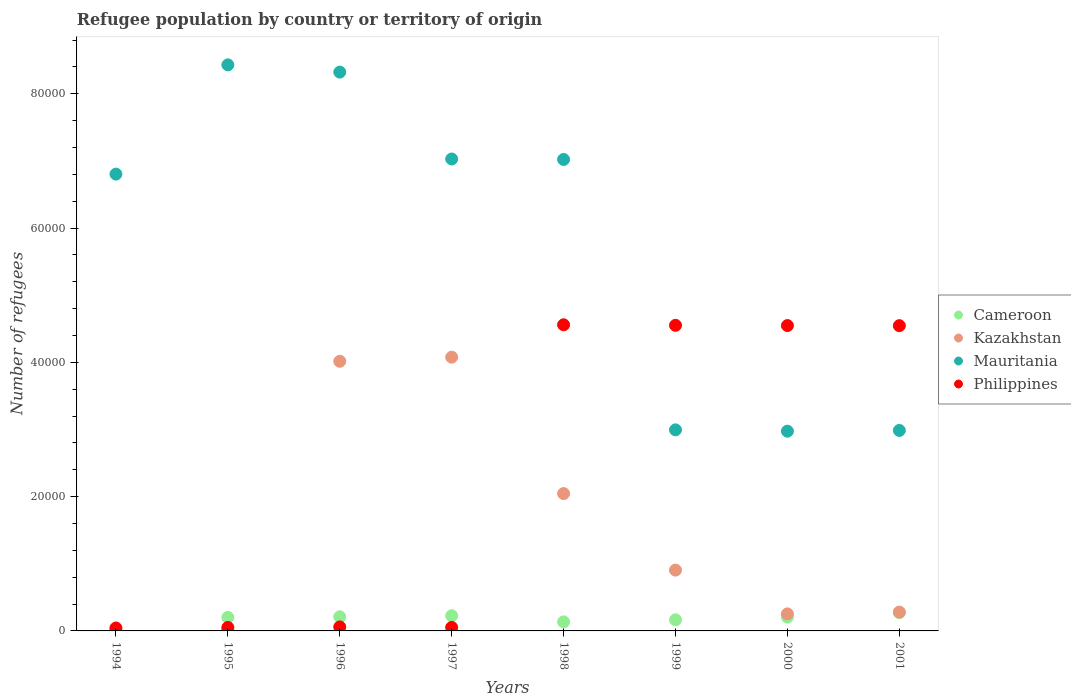How many different coloured dotlines are there?
Offer a terse response. 4. What is the number of refugees in Mauritania in 1994?
Provide a short and direct response. 6.80e+04. Across all years, what is the maximum number of refugees in Philippines?
Your answer should be compact. 4.56e+04. Across all years, what is the minimum number of refugees in Cameroon?
Provide a short and direct response. 238. In which year was the number of refugees in Mauritania maximum?
Your response must be concise. 1995. In which year was the number of refugees in Mauritania minimum?
Keep it short and to the point. 2000. What is the total number of refugees in Mauritania in the graph?
Your answer should be compact. 4.66e+05. What is the difference between the number of refugees in Mauritania in 1994 and that in 2000?
Your answer should be very brief. 3.83e+04. What is the difference between the number of refugees in Cameroon in 1998 and the number of refugees in Kazakhstan in 2001?
Offer a terse response. -1455. What is the average number of refugees in Mauritania per year?
Your answer should be very brief. 5.82e+04. In the year 1997, what is the difference between the number of refugees in Mauritania and number of refugees in Philippines?
Offer a very short reply. 6.98e+04. In how many years, is the number of refugees in Philippines greater than 28000?
Offer a very short reply. 4. What is the ratio of the number of refugees in Cameroon in 2000 to that in 2001?
Your answer should be very brief. 0.76. Is the number of refugees in Philippines in 1995 less than that in 1998?
Offer a very short reply. Yes. What is the difference between the highest and the second highest number of refugees in Cameroon?
Your answer should be compact. 466. What is the difference between the highest and the lowest number of refugees in Kazakhstan?
Provide a succinct answer. 4.07e+04. Does the number of refugees in Cameroon monotonically increase over the years?
Ensure brevity in your answer.  No. Is the number of refugees in Mauritania strictly greater than the number of refugees in Cameroon over the years?
Make the answer very short. Yes. Is the number of refugees in Philippines strictly less than the number of refugees in Mauritania over the years?
Ensure brevity in your answer.  No. How many dotlines are there?
Keep it short and to the point. 4. How many years are there in the graph?
Keep it short and to the point. 8. Are the values on the major ticks of Y-axis written in scientific E-notation?
Provide a short and direct response. No. How many legend labels are there?
Keep it short and to the point. 4. What is the title of the graph?
Ensure brevity in your answer.  Refugee population by country or territory of origin. Does "Central African Republic" appear as one of the legend labels in the graph?
Offer a terse response. No. What is the label or title of the X-axis?
Provide a succinct answer. Years. What is the label or title of the Y-axis?
Offer a very short reply. Number of refugees. What is the Number of refugees in Cameroon in 1994?
Your answer should be very brief. 238. What is the Number of refugees in Kazakhstan in 1994?
Ensure brevity in your answer.  27. What is the Number of refugees in Mauritania in 1994?
Your response must be concise. 6.80e+04. What is the Number of refugees of Philippines in 1994?
Your answer should be very brief. 436. What is the Number of refugees of Cameroon in 1995?
Ensure brevity in your answer.  2017. What is the Number of refugees in Kazakhstan in 1995?
Provide a succinct answer. 139. What is the Number of refugees in Mauritania in 1995?
Ensure brevity in your answer.  8.43e+04. What is the Number of refugees of Philippines in 1995?
Give a very brief answer. 516. What is the Number of refugees of Cameroon in 1996?
Your answer should be very brief. 2109. What is the Number of refugees of Kazakhstan in 1996?
Make the answer very short. 4.02e+04. What is the Number of refugees of Mauritania in 1996?
Give a very brief answer. 8.32e+04. What is the Number of refugees in Philippines in 1996?
Your response must be concise. 598. What is the Number of refugees of Cameroon in 1997?
Your answer should be compact. 2258. What is the Number of refugees of Kazakhstan in 1997?
Ensure brevity in your answer.  4.08e+04. What is the Number of refugees of Mauritania in 1997?
Provide a succinct answer. 7.03e+04. What is the Number of refugees of Philippines in 1997?
Your answer should be very brief. 525. What is the Number of refugees of Cameroon in 1998?
Your answer should be compact. 1348. What is the Number of refugees of Kazakhstan in 1998?
Offer a very short reply. 2.05e+04. What is the Number of refugees of Mauritania in 1998?
Provide a short and direct response. 7.02e+04. What is the Number of refugees in Philippines in 1998?
Give a very brief answer. 4.56e+04. What is the Number of refugees of Cameroon in 1999?
Provide a short and direct response. 1654. What is the Number of refugees in Kazakhstan in 1999?
Your response must be concise. 9057. What is the Number of refugees of Mauritania in 1999?
Offer a very short reply. 2.99e+04. What is the Number of refugees in Philippines in 1999?
Your response must be concise. 4.55e+04. What is the Number of refugees of Cameroon in 2000?
Give a very brief answer. 2062. What is the Number of refugees in Kazakhstan in 2000?
Keep it short and to the point. 2537. What is the Number of refugees in Mauritania in 2000?
Your response must be concise. 2.98e+04. What is the Number of refugees of Philippines in 2000?
Offer a very short reply. 4.55e+04. What is the Number of refugees in Cameroon in 2001?
Ensure brevity in your answer.  2724. What is the Number of refugees of Kazakhstan in 2001?
Keep it short and to the point. 2803. What is the Number of refugees of Mauritania in 2001?
Offer a very short reply. 2.99e+04. What is the Number of refugees in Philippines in 2001?
Offer a very short reply. 4.55e+04. Across all years, what is the maximum Number of refugees in Cameroon?
Your answer should be very brief. 2724. Across all years, what is the maximum Number of refugees in Kazakhstan?
Make the answer very short. 4.08e+04. Across all years, what is the maximum Number of refugees of Mauritania?
Offer a terse response. 8.43e+04. Across all years, what is the maximum Number of refugees of Philippines?
Provide a short and direct response. 4.56e+04. Across all years, what is the minimum Number of refugees of Cameroon?
Your answer should be compact. 238. Across all years, what is the minimum Number of refugees in Kazakhstan?
Ensure brevity in your answer.  27. Across all years, what is the minimum Number of refugees in Mauritania?
Your response must be concise. 2.98e+04. Across all years, what is the minimum Number of refugees in Philippines?
Your answer should be very brief. 436. What is the total Number of refugees of Cameroon in the graph?
Offer a terse response. 1.44e+04. What is the total Number of refugees in Kazakhstan in the graph?
Ensure brevity in your answer.  1.16e+05. What is the total Number of refugees in Mauritania in the graph?
Your answer should be compact. 4.66e+05. What is the total Number of refugees in Philippines in the graph?
Provide a short and direct response. 1.84e+05. What is the difference between the Number of refugees of Cameroon in 1994 and that in 1995?
Ensure brevity in your answer.  -1779. What is the difference between the Number of refugees in Kazakhstan in 1994 and that in 1995?
Your answer should be very brief. -112. What is the difference between the Number of refugees of Mauritania in 1994 and that in 1995?
Make the answer very short. -1.63e+04. What is the difference between the Number of refugees in Philippines in 1994 and that in 1995?
Provide a short and direct response. -80. What is the difference between the Number of refugees in Cameroon in 1994 and that in 1996?
Give a very brief answer. -1871. What is the difference between the Number of refugees in Kazakhstan in 1994 and that in 1996?
Provide a succinct answer. -4.01e+04. What is the difference between the Number of refugees in Mauritania in 1994 and that in 1996?
Provide a short and direct response. -1.52e+04. What is the difference between the Number of refugees of Philippines in 1994 and that in 1996?
Provide a short and direct response. -162. What is the difference between the Number of refugees in Cameroon in 1994 and that in 1997?
Your response must be concise. -2020. What is the difference between the Number of refugees in Kazakhstan in 1994 and that in 1997?
Your answer should be compact. -4.07e+04. What is the difference between the Number of refugees in Mauritania in 1994 and that in 1997?
Make the answer very short. -2251. What is the difference between the Number of refugees in Philippines in 1994 and that in 1997?
Make the answer very short. -89. What is the difference between the Number of refugees of Cameroon in 1994 and that in 1998?
Your answer should be compact. -1110. What is the difference between the Number of refugees in Kazakhstan in 1994 and that in 1998?
Make the answer very short. -2.04e+04. What is the difference between the Number of refugees of Mauritania in 1994 and that in 1998?
Your answer should be very brief. -2181. What is the difference between the Number of refugees of Philippines in 1994 and that in 1998?
Give a very brief answer. -4.52e+04. What is the difference between the Number of refugees in Cameroon in 1994 and that in 1999?
Offer a very short reply. -1416. What is the difference between the Number of refugees in Kazakhstan in 1994 and that in 1999?
Offer a terse response. -9030. What is the difference between the Number of refugees of Mauritania in 1994 and that in 1999?
Your response must be concise. 3.81e+04. What is the difference between the Number of refugees in Philippines in 1994 and that in 1999?
Offer a very short reply. -4.51e+04. What is the difference between the Number of refugees of Cameroon in 1994 and that in 2000?
Offer a very short reply. -1824. What is the difference between the Number of refugees in Kazakhstan in 1994 and that in 2000?
Give a very brief answer. -2510. What is the difference between the Number of refugees of Mauritania in 1994 and that in 2000?
Your answer should be compact. 3.83e+04. What is the difference between the Number of refugees of Philippines in 1994 and that in 2000?
Offer a very short reply. -4.50e+04. What is the difference between the Number of refugees of Cameroon in 1994 and that in 2001?
Ensure brevity in your answer.  -2486. What is the difference between the Number of refugees of Kazakhstan in 1994 and that in 2001?
Offer a terse response. -2776. What is the difference between the Number of refugees of Mauritania in 1994 and that in 2001?
Provide a succinct answer. 3.82e+04. What is the difference between the Number of refugees in Philippines in 1994 and that in 2001?
Keep it short and to the point. -4.50e+04. What is the difference between the Number of refugees in Cameroon in 1995 and that in 1996?
Your response must be concise. -92. What is the difference between the Number of refugees in Kazakhstan in 1995 and that in 1996?
Provide a succinct answer. -4.00e+04. What is the difference between the Number of refugees of Mauritania in 1995 and that in 1996?
Offer a terse response. 1078. What is the difference between the Number of refugees in Philippines in 1995 and that in 1996?
Keep it short and to the point. -82. What is the difference between the Number of refugees in Cameroon in 1995 and that in 1997?
Your answer should be compact. -241. What is the difference between the Number of refugees of Kazakhstan in 1995 and that in 1997?
Your answer should be very brief. -4.06e+04. What is the difference between the Number of refugees of Mauritania in 1995 and that in 1997?
Your response must be concise. 1.40e+04. What is the difference between the Number of refugees of Philippines in 1995 and that in 1997?
Ensure brevity in your answer.  -9. What is the difference between the Number of refugees in Cameroon in 1995 and that in 1998?
Offer a very short reply. 669. What is the difference between the Number of refugees in Kazakhstan in 1995 and that in 1998?
Make the answer very short. -2.03e+04. What is the difference between the Number of refugees of Mauritania in 1995 and that in 1998?
Ensure brevity in your answer.  1.41e+04. What is the difference between the Number of refugees in Philippines in 1995 and that in 1998?
Offer a very short reply. -4.51e+04. What is the difference between the Number of refugees of Cameroon in 1995 and that in 1999?
Give a very brief answer. 363. What is the difference between the Number of refugees in Kazakhstan in 1995 and that in 1999?
Keep it short and to the point. -8918. What is the difference between the Number of refugees of Mauritania in 1995 and that in 1999?
Ensure brevity in your answer.  5.44e+04. What is the difference between the Number of refugees of Philippines in 1995 and that in 1999?
Your answer should be very brief. -4.50e+04. What is the difference between the Number of refugees of Cameroon in 1995 and that in 2000?
Your answer should be very brief. -45. What is the difference between the Number of refugees in Kazakhstan in 1995 and that in 2000?
Make the answer very short. -2398. What is the difference between the Number of refugees in Mauritania in 1995 and that in 2000?
Ensure brevity in your answer.  5.46e+04. What is the difference between the Number of refugees of Philippines in 1995 and that in 2000?
Your answer should be compact. -4.50e+04. What is the difference between the Number of refugees of Cameroon in 1995 and that in 2001?
Offer a very short reply. -707. What is the difference between the Number of refugees in Kazakhstan in 1995 and that in 2001?
Ensure brevity in your answer.  -2664. What is the difference between the Number of refugees in Mauritania in 1995 and that in 2001?
Your response must be concise. 5.44e+04. What is the difference between the Number of refugees of Philippines in 1995 and that in 2001?
Ensure brevity in your answer.  -4.50e+04. What is the difference between the Number of refugees in Cameroon in 1996 and that in 1997?
Make the answer very short. -149. What is the difference between the Number of refugees in Kazakhstan in 1996 and that in 1997?
Give a very brief answer. -611. What is the difference between the Number of refugees in Mauritania in 1996 and that in 1997?
Make the answer very short. 1.29e+04. What is the difference between the Number of refugees of Cameroon in 1996 and that in 1998?
Your response must be concise. 761. What is the difference between the Number of refugees of Kazakhstan in 1996 and that in 1998?
Give a very brief answer. 1.97e+04. What is the difference between the Number of refugees of Mauritania in 1996 and that in 1998?
Your answer should be compact. 1.30e+04. What is the difference between the Number of refugees of Philippines in 1996 and that in 1998?
Offer a terse response. -4.50e+04. What is the difference between the Number of refugees in Cameroon in 1996 and that in 1999?
Give a very brief answer. 455. What is the difference between the Number of refugees of Kazakhstan in 1996 and that in 1999?
Offer a very short reply. 3.11e+04. What is the difference between the Number of refugees in Mauritania in 1996 and that in 1999?
Offer a terse response. 5.33e+04. What is the difference between the Number of refugees in Philippines in 1996 and that in 1999?
Keep it short and to the point. -4.49e+04. What is the difference between the Number of refugees of Cameroon in 1996 and that in 2000?
Provide a succinct answer. 47. What is the difference between the Number of refugees in Kazakhstan in 1996 and that in 2000?
Provide a short and direct response. 3.76e+04. What is the difference between the Number of refugees of Mauritania in 1996 and that in 2000?
Offer a terse response. 5.35e+04. What is the difference between the Number of refugees of Philippines in 1996 and that in 2000?
Make the answer very short. -4.49e+04. What is the difference between the Number of refugees in Cameroon in 1996 and that in 2001?
Make the answer very short. -615. What is the difference between the Number of refugees in Kazakhstan in 1996 and that in 2001?
Provide a succinct answer. 3.74e+04. What is the difference between the Number of refugees in Mauritania in 1996 and that in 2001?
Keep it short and to the point. 5.34e+04. What is the difference between the Number of refugees in Philippines in 1996 and that in 2001?
Offer a terse response. -4.49e+04. What is the difference between the Number of refugees of Cameroon in 1997 and that in 1998?
Provide a short and direct response. 910. What is the difference between the Number of refugees of Kazakhstan in 1997 and that in 1998?
Provide a short and direct response. 2.03e+04. What is the difference between the Number of refugees of Mauritania in 1997 and that in 1998?
Make the answer very short. 70. What is the difference between the Number of refugees in Philippines in 1997 and that in 1998?
Your answer should be compact. -4.51e+04. What is the difference between the Number of refugees of Cameroon in 1997 and that in 1999?
Give a very brief answer. 604. What is the difference between the Number of refugees of Kazakhstan in 1997 and that in 1999?
Your answer should be very brief. 3.17e+04. What is the difference between the Number of refugees in Mauritania in 1997 and that in 1999?
Provide a short and direct response. 4.03e+04. What is the difference between the Number of refugees in Philippines in 1997 and that in 1999?
Your response must be concise. -4.50e+04. What is the difference between the Number of refugees in Cameroon in 1997 and that in 2000?
Offer a very short reply. 196. What is the difference between the Number of refugees of Kazakhstan in 1997 and that in 2000?
Provide a short and direct response. 3.82e+04. What is the difference between the Number of refugees of Mauritania in 1997 and that in 2000?
Keep it short and to the point. 4.05e+04. What is the difference between the Number of refugees of Philippines in 1997 and that in 2000?
Keep it short and to the point. -4.50e+04. What is the difference between the Number of refugees in Cameroon in 1997 and that in 2001?
Keep it short and to the point. -466. What is the difference between the Number of refugees of Kazakhstan in 1997 and that in 2001?
Provide a succinct answer. 3.80e+04. What is the difference between the Number of refugees in Mauritania in 1997 and that in 2001?
Make the answer very short. 4.04e+04. What is the difference between the Number of refugees of Philippines in 1997 and that in 2001?
Your answer should be compact. -4.49e+04. What is the difference between the Number of refugees in Cameroon in 1998 and that in 1999?
Keep it short and to the point. -306. What is the difference between the Number of refugees in Kazakhstan in 1998 and that in 1999?
Keep it short and to the point. 1.14e+04. What is the difference between the Number of refugees in Mauritania in 1998 and that in 1999?
Make the answer very short. 4.03e+04. What is the difference between the Number of refugees in Philippines in 1998 and that in 1999?
Keep it short and to the point. 78. What is the difference between the Number of refugees in Cameroon in 1998 and that in 2000?
Ensure brevity in your answer.  -714. What is the difference between the Number of refugees in Kazakhstan in 1998 and that in 2000?
Offer a very short reply. 1.79e+04. What is the difference between the Number of refugees in Mauritania in 1998 and that in 2000?
Your answer should be compact. 4.05e+04. What is the difference between the Number of refugees in Philippines in 1998 and that in 2000?
Make the answer very short. 116. What is the difference between the Number of refugees in Cameroon in 1998 and that in 2001?
Make the answer very short. -1376. What is the difference between the Number of refugees in Kazakhstan in 1998 and that in 2001?
Your answer should be very brief. 1.77e+04. What is the difference between the Number of refugees in Mauritania in 1998 and that in 2001?
Your answer should be very brief. 4.04e+04. What is the difference between the Number of refugees of Philippines in 1998 and that in 2001?
Provide a short and direct response. 131. What is the difference between the Number of refugees of Cameroon in 1999 and that in 2000?
Provide a succinct answer. -408. What is the difference between the Number of refugees in Kazakhstan in 1999 and that in 2000?
Your answer should be compact. 6520. What is the difference between the Number of refugees in Mauritania in 1999 and that in 2000?
Provide a succinct answer. 196. What is the difference between the Number of refugees of Philippines in 1999 and that in 2000?
Your answer should be compact. 38. What is the difference between the Number of refugees of Cameroon in 1999 and that in 2001?
Your answer should be very brief. -1070. What is the difference between the Number of refugees in Kazakhstan in 1999 and that in 2001?
Keep it short and to the point. 6254. What is the difference between the Number of refugees of Cameroon in 2000 and that in 2001?
Keep it short and to the point. -662. What is the difference between the Number of refugees of Kazakhstan in 2000 and that in 2001?
Ensure brevity in your answer.  -266. What is the difference between the Number of refugees in Mauritania in 2000 and that in 2001?
Your answer should be compact. -110. What is the difference between the Number of refugees in Philippines in 2000 and that in 2001?
Give a very brief answer. 15. What is the difference between the Number of refugees of Cameroon in 1994 and the Number of refugees of Kazakhstan in 1995?
Your answer should be compact. 99. What is the difference between the Number of refugees of Cameroon in 1994 and the Number of refugees of Mauritania in 1995?
Keep it short and to the point. -8.41e+04. What is the difference between the Number of refugees of Cameroon in 1994 and the Number of refugees of Philippines in 1995?
Offer a terse response. -278. What is the difference between the Number of refugees of Kazakhstan in 1994 and the Number of refugees of Mauritania in 1995?
Your answer should be compact. -8.43e+04. What is the difference between the Number of refugees of Kazakhstan in 1994 and the Number of refugees of Philippines in 1995?
Offer a very short reply. -489. What is the difference between the Number of refugees in Mauritania in 1994 and the Number of refugees in Philippines in 1995?
Provide a succinct answer. 6.75e+04. What is the difference between the Number of refugees in Cameroon in 1994 and the Number of refugees in Kazakhstan in 1996?
Your answer should be very brief. -3.99e+04. What is the difference between the Number of refugees of Cameroon in 1994 and the Number of refugees of Mauritania in 1996?
Offer a terse response. -8.30e+04. What is the difference between the Number of refugees in Cameroon in 1994 and the Number of refugees in Philippines in 1996?
Provide a succinct answer. -360. What is the difference between the Number of refugees in Kazakhstan in 1994 and the Number of refugees in Mauritania in 1996?
Your answer should be compact. -8.32e+04. What is the difference between the Number of refugees in Kazakhstan in 1994 and the Number of refugees in Philippines in 1996?
Your response must be concise. -571. What is the difference between the Number of refugees in Mauritania in 1994 and the Number of refugees in Philippines in 1996?
Give a very brief answer. 6.74e+04. What is the difference between the Number of refugees in Cameroon in 1994 and the Number of refugees in Kazakhstan in 1997?
Offer a very short reply. -4.05e+04. What is the difference between the Number of refugees in Cameroon in 1994 and the Number of refugees in Mauritania in 1997?
Provide a short and direct response. -7.01e+04. What is the difference between the Number of refugees in Cameroon in 1994 and the Number of refugees in Philippines in 1997?
Make the answer very short. -287. What is the difference between the Number of refugees of Kazakhstan in 1994 and the Number of refugees of Mauritania in 1997?
Offer a very short reply. -7.03e+04. What is the difference between the Number of refugees in Kazakhstan in 1994 and the Number of refugees in Philippines in 1997?
Offer a terse response. -498. What is the difference between the Number of refugees of Mauritania in 1994 and the Number of refugees of Philippines in 1997?
Give a very brief answer. 6.75e+04. What is the difference between the Number of refugees of Cameroon in 1994 and the Number of refugees of Kazakhstan in 1998?
Give a very brief answer. -2.02e+04. What is the difference between the Number of refugees in Cameroon in 1994 and the Number of refugees in Mauritania in 1998?
Offer a terse response. -7.00e+04. What is the difference between the Number of refugees of Cameroon in 1994 and the Number of refugees of Philippines in 1998?
Provide a short and direct response. -4.54e+04. What is the difference between the Number of refugees of Kazakhstan in 1994 and the Number of refugees of Mauritania in 1998?
Give a very brief answer. -7.02e+04. What is the difference between the Number of refugees of Kazakhstan in 1994 and the Number of refugees of Philippines in 1998?
Provide a succinct answer. -4.56e+04. What is the difference between the Number of refugees in Mauritania in 1994 and the Number of refugees in Philippines in 1998?
Your response must be concise. 2.24e+04. What is the difference between the Number of refugees of Cameroon in 1994 and the Number of refugees of Kazakhstan in 1999?
Keep it short and to the point. -8819. What is the difference between the Number of refugees in Cameroon in 1994 and the Number of refugees in Mauritania in 1999?
Your answer should be very brief. -2.97e+04. What is the difference between the Number of refugees of Cameroon in 1994 and the Number of refugees of Philippines in 1999?
Offer a very short reply. -4.53e+04. What is the difference between the Number of refugees of Kazakhstan in 1994 and the Number of refugees of Mauritania in 1999?
Your answer should be compact. -2.99e+04. What is the difference between the Number of refugees in Kazakhstan in 1994 and the Number of refugees in Philippines in 1999?
Your answer should be very brief. -4.55e+04. What is the difference between the Number of refugees in Mauritania in 1994 and the Number of refugees in Philippines in 1999?
Your answer should be compact. 2.25e+04. What is the difference between the Number of refugees in Cameroon in 1994 and the Number of refugees in Kazakhstan in 2000?
Offer a very short reply. -2299. What is the difference between the Number of refugees of Cameroon in 1994 and the Number of refugees of Mauritania in 2000?
Your answer should be compact. -2.95e+04. What is the difference between the Number of refugees of Cameroon in 1994 and the Number of refugees of Philippines in 2000?
Your answer should be compact. -4.52e+04. What is the difference between the Number of refugees in Kazakhstan in 1994 and the Number of refugees in Mauritania in 2000?
Provide a short and direct response. -2.97e+04. What is the difference between the Number of refugees in Kazakhstan in 1994 and the Number of refugees in Philippines in 2000?
Keep it short and to the point. -4.55e+04. What is the difference between the Number of refugees in Mauritania in 1994 and the Number of refugees in Philippines in 2000?
Give a very brief answer. 2.26e+04. What is the difference between the Number of refugees of Cameroon in 1994 and the Number of refugees of Kazakhstan in 2001?
Offer a very short reply. -2565. What is the difference between the Number of refugees in Cameroon in 1994 and the Number of refugees in Mauritania in 2001?
Your response must be concise. -2.96e+04. What is the difference between the Number of refugees of Cameroon in 1994 and the Number of refugees of Philippines in 2001?
Make the answer very short. -4.52e+04. What is the difference between the Number of refugees in Kazakhstan in 1994 and the Number of refugees in Mauritania in 2001?
Offer a terse response. -2.98e+04. What is the difference between the Number of refugees of Kazakhstan in 1994 and the Number of refugees of Philippines in 2001?
Provide a short and direct response. -4.54e+04. What is the difference between the Number of refugees in Mauritania in 1994 and the Number of refugees in Philippines in 2001?
Give a very brief answer. 2.26e+04. What is the difference between the Number of refugees in Cameroon in 1995 and the Number of refugees in Kazakhstan in 1996?
Offer a terse response. -3.81e+04. What is the difference between the Number of refugees in Cameroon in 1995 and the Number of refugees in Mauritania in 1996?
Your response must be concise. -8.12e+04. What is the difference between the Number of refugees of Cameroon in 1995 and the Number of refugees of Philippines in 1996?
Provide a succinct answer. 1419. What is the difference between the Number of refugees of Kazakhstan in 1995 and the Number of refugees of Mauritania in 1996?
Offer a very short reply. -8.31e+04. What is the difference between the Number of refugees of Kazakhstan in 1995 and the Number of refugees of Philippines in 1996?
Keep it short and to the point. -459. What is the difference between the Number of refugees in Mauritania in 1995 and the Number of refugees in Philippines in 1996?
Keep it short and to the point. 8.37e+04. What is the difference between the Number of refugees of Cameroon in 1995 and the Number of refugees of Kazakhstan in 1997?
Keep it short and to the point. -3.88e+04. What is the difference between the Number of refugees in Cameroon in 1995 and the Number of refugees in Mauritania in 1997?
Keep it short and to the point. -6.83e+04. What is the difference between the Number of refugees in Cameroon in 1995 and the Number of refugees in Philippines in 1997?
Offer a very short reply. 1492. What is the difference between the Number of refugees of Kazakhstan in 1995 and the Number of refugees of Mauritania in 1997?
Offer a very short reply. -7.02e+04. What is the difference between the Number of refugees in Kazakhstan in 1995 and the Number of refugees in Philippines in 1997?
Keep it short and to the point. -386. What is the difference between the Number of refugees of Mauritania in 1995 and the Number of refugees of Philippines in 1997?
Offer a very short reply. 8.38e+04. What is the difference between the Number of refugees of Cameroon in 1995 and the Number of refugees of Kazakhstan in 1998?
Offer a very short reply. -1.84e+04. What is the difference between the Number of refugees of Cameroon in 1995 and the Number of refugees of Mauritania in 1998?
Your answer should be very brief. -6.82e+04. What is the difference between the Number of refugees of Cameroon in 1995 and the Number of refugees of Philippines in 1998?
Your answer should be compact. -4.36e+04. What is the difference between the Number of refugees of Kazakhstan in 1995 and the Number of refugees of Mauritania in 1998?
Offer a terse response. -7.01e+04. What is the difference between the Number of refugees of Kazakhstan in 1995 and the Number of refugees of Philippines in 1998?
Offer a very short reply. -4.55e+04. What is the difference between the Number of refugees of Mauritania in 1995 and the Number of refugees of Philippines in 1998?
Provide a succinct answer. 3.87e+04. What is the difference between the Number of refugees of Cameroon in 1995 and the Number of refugees of Kazakhstan in 1999?
Keep it short and to the point. -7040. What is the difference between the Number of refugees in Cameroon in 1995 and the Number of refugees in Mauritania in 1999?
Ensure brevity in your answer.  -2.79e+04. What is the difference between the Number of refugees in Cameroon in 1995 and the Number of refugees in Philippines in 1999?
Provide a short and direct response. -4.35e+04. What is the difference between the Number of refugees of Kazakhstan in 1995 and the Number of refugees of Mauritania in 1999?
Make the answer very short. -2.98e+04. What is the difference between the Number of refugees of Kazakhstan in 1995 and the Number of refugees of Philippines in 1999?
Offer a terse response. -4.54e+04. What is the difference between the Number of refugees in Mauritania in 1995 and the Number of refugees in Philippines in 1999?
Offer a very short reply. 3.88e+04. What is the difference between the Number of refugees in Cameroon in 1995 and the Number of refugees in Kazakhstan in 2000?
Your response must be concise. -520. What is the difference between the Number of refugees in Cameroon in 1995 and the Number of refugees in Mauritania in 2000?
Provide a succinct answer. -2.77e+04. What is the difference between the Number of refugees in Cameroon in 1995 and the Number of refugees in Philippines in 2000?
Your answer should be compact. -4.35e+04. What is the difference between the Number of refugees of Kazakhstan in 1995 and the Number of refugees of Mauritania in 2000?
Offer a terse response. -2.96e+04. What is the difference between the Number of refugees in Kazakhstan in 1995 and the Number of refugees in Philippines in 2000?
Your answer should be very brief. -4.53e+04. What is the difference between the Number of refugees in Mauritania in 1995 and the Number of refugees in Philippines in 2000?
Your answer should be very brief. 3.88e+04. What is the difference between the Number of refugees of Cameroon in 1995 and the Number of refugees of Kazakhstan in 2001?
Give a very brief answer. -786. What is the difference between the Number of refugees in Cameroon in 1995 and the Number of refugees in Mauritania in 2001?
Give a very brief answer. -2.78e+04. What is the difference between the Number of refugees of Cameroon in 1995 and the Number of refugees of Philippines in 2001?
Offer a terse response. -4.34e+04. What is the difference between the Number of refugees of Kazakhstan in 1995 and the Number of refugees of Mauritania in 2001?
Offer a very short reply. -2.97e+04. What is the difference between the Number of refugees in Kazakhstan in 1995 and the Number of refugees in Philippines in 2001?
Provide a short and direct response. -4.53e+04. What is the difference between the Number of refugees of Mauritania in 1995 and the Number of refugees of Philippines in 2001?
Offer a very short reply. 3.88e+04. What is the difference between the Number of refugees in Cameroon in 1996 and the Number of refugees in Kazakhstan in 1997?
Your answer should be very brief. -3.87e+04. What is the difference between the Number of refugees in Cameroon in 1996 and the Number of refugees in Mauritania in 1997?
Provide a succinct answer. -6.82e+04. What is the difference between the Number of refugees of Cameroon in 1996 and the Number of refugees of Philippines in 1997?
Offer a terse response. 1584. What is the difference between the Number of refugees of Kazakhstan in 1996 and the Number of refugees of Mauritania in 1997?
Your answer should be very brief. -3.01e+04. What is the difference between the Number of refugees in Kazakhstan in 1996 and the Number of refugees in Philippines in 1997?
Keep it short and to the point. 3.96e+04. What is the difference between the Number of refugees in Mauritania in 1996 and the Number of refugees in Philippines in 1997?
Ensure brevity in your answer.  8.27e+04. What is the difference between the Number of refugees in Cameroon in 1996 and the Number of refugees in Kazakhstan in 1998?
Your answer should be very brief. -1.84e+04. What is the difference between the Number of refugees of Cameroon in 1996 and the Number of refugees of Mauritania in 1998?
Provide a short and direct response. -6.81e+04. What is the difference between the Number of refugees in Cameroon in 1996 and the Number of refugees in Philippines in 1998?
Offer a very short reply. -4.35e+04. What is the difference between the Number of refugees in Kazakhstan in 1996 and the Number of refugees in Mauritania in 1998?
Offer a very short reply. -3.01e+04. What is the difference between the Number of refugees of Kazakhstan in 1996 and the Number of refugees of Philippines in 1998?
Provide a short and direct response. -5435. What is the difference between the Number of refugees in Mauritania in 1996 and the Number of refugees in Philippines in 1998?
Your answer should be very brief. 3.76e+04. What is the difference between the Number of refugees of Cameroon in 1996 and the Number of refugees of Kazakhstan in 1999?
Provide a succinct answer. -6948. What is the difference between the Number of refugees of Cameroon in 1996 and the Number of refugees of Mauritania in 1999?
Your response must be concise. -2.78e+04. What is the difference between the Number of refugees of Cameroon in 1996 and the Number of refugees of Philippines in 1999?
Your response must be concise. -4.34e+04. What is the difference between the Number of refugees of Kazakhstan in 1996 and the Number of refugees of Mauritania in 1999?
Provide a succinct answer. 1.02e+04. What is the difference between the Number of refugees in Kazakhstan in 1996 and the Number of refugees in Philippines in 1999?
Give a very brief answer. -5357. What is the difference between the Number of refugees in Mauritania in 1996 and the Number of refugees in Philippines in 1999?
Make the answer very short. 3.77e+04. What is the difference between the Number of refugees of Cameroon in 1996 and the Number of refugees of Kazakhstan in 2000?
Offer a very short reply. -428. What is the difference between the Number of refugees of Cameroon in 1996 and the Number of refugees of Mauritania in 2000?
Provide a succinct answer. -2.76e+04. What is the difference between the Number of refugees in Cameroon in 1996 and the Number of refugees in Philippines in 2000?
Your answer should be very brief. -4.34e+04. What is the difference between the Number of refugees in Kazakhstan in 1996 and the Number of refugees in Mauritania in 2000?
Provide a short and direct response. 1.04e+04. What is the difference between the Number of refugees in Kazakhstan in 1996 and the Number of refugees in Philippines in 2000?
Your response must be concise. -5319. What is the difference between the Number of refugees of Mauritania in 1996 and the Number of refugees of Philippines in 2000?
Ensure brevity in your answer.  3.78e+04. What is the difference between the Number of refugees in Cameroon in 1996 and the Number of refugees in Kazakhstan in 2001?
Keep it short and to the point. -694. What is the difference between the Number of refugees in Cameroon in 1996 and the Number of refugees in Mauritania in 2001?
Keep it short and to the point. -2.78e+04. What is the difference between the Number of refugees of Cameroon in 1996 and the Number of refugees of Philippines in 2001?
Your answer should be compact. -4.34e+04. What is the difference between the Number of refugees in Kazakhstan in 1996 and the Number of refugees in Mauritania in 2001?
Your answer should be compact. 1.03e+04. What is the difference between the Number of refugees of Kazakhstan in 1996 and the Number of refugees of Philippines in 2001?
Your answer should be very brief. -5304. What is the difference between the Number of refugees in Mauritania in 1996 and the Number of refugees in Philippines in 2001?
Make the answer very short. 3.78e+04. What is the difference between the Number of refugees of Cameroon in 1997 and the Number of refugees of Kazakhstan in 1998?
Your answer should be very brief. -1.82e+04. What is the difference between the Number of refugees in Cameroon in 1997 and the Number of refugees in Mauritania in 1998?
Your answer should be very brief. -6.80e+04. What is the difference between the Number of refugees in Cameroon in 1997 and the Number of refugees in Philippines in 1998?
Your answer should be compact. -4.33e+04. What is the difference between the Number of refugees in Kazakhstan in 1997 and the Number of refugees in Mauritania in 1998?
Keep it short and to the point. -2.94e+04. What is the difference between the Number of refugees of Kazakhstan in 1997 and the Number of refugees of Philippines in 1998?
Offer a terse response. -4824. What is the difference between the Number of refugees in Mauritania in 1997 and the Number of refugees in Philippines in 1998?
Give a very brief answer. 2.47e+04. What is the difference between the Number of refugees in Cameroon in 1997 and the Number of refugees in Kazakhstan in 1999?
Provide a short and direct response. -6799. What is the difference between the Number of refugees of Cameroon in 1997 and the Number of refugees of Mauritania in 1999?
Keep it short and to the point. -2.77e+04. What is the difference between the Number of refugees of Cameroon in 1997 and the Number of refugees of Philippines in 1999?
Offer a very short reply. -4.33e+04. What is the difference between the Number of refugees in Kazakhstan in 1997 and the Number of refugees in Mauritania in 1999?
Your response must be concise. 1.08e+04. What is the difference between the Number of refugees of Kazakhstan in 1997 and the Number of refugees of Philippines in 1999?
Give a very brief answer. -4746. What is the difference between the Number of refugees of Mauritania in 1997 and the Number of refugees of Philippines in 1999?
Your answer should be compact. 2.48e+04. What is the difference between the Number of refugees in Cameroon in 1997 and the Number of refugees in Kazakhstan in 2000?
Give a very brief answer. -279. What is the difference between the Number of refugees in Cameroon in 1997 and the Number of refugees in Mauritania in 2000?
Ensure brevity in your answer.  -2.75e+04. What is the difference between the Number of refugees of Cameroon in 1997 and the Number of refugees of Philippines in 2000?
Offer a terse response. -4.32e+04. What is the difference between the Number of refugees in Kazakhstan in 1997 and the Number of refugees in Mauritania in 2000?
Make the answer very short. 1.10e+04. What is the difference between the Number of refugees in Kazakhstan in 1997 and the Number of refugees in Philippines in 2000?
Provide a short and direct response. -4708. What is the difference between the Number of refugees in Mauritania in 1997 and the Number of refugees in Philippines in 2000?
Offer a terse response. 2.48e+04. What is the difference between the Number of refugees in Cameroon in 1997 and the Number of refugees in Kazakhstan in 2001?
Offer a terse response. -545. What is the difference between the Number of refugees of Cameroon in 1997 and the Number of refugees of Mauritania in 2001?
Offer a very short reply. -2.76e+04. What is the difference between the Number of refugees in Cameroon in 1997 and the Number of refugees in Philippines in 2001?
Your response must be concise. -4.32e+04. What is the difference between the Number of refugees in Kazakhstan in 1997 and the Number of refugees in Mauritania in 2001?
Make the answer very short. 1.09e+04. What is the difference between the Number of refugees of Kazakhstan in 1997 and the Number of refugees of Philippines in 2001?
Ensure brevity in your answer.  -4693. What is the difference between the Number of refugees in Mauritania in 1997 and the Number of refugees in Philippines in 2001?
Your response must be concise. 2.48e+04. What is the difference between the Number of refugees in Cameroon in 1998 and the Number of refugees in Kazakhstan in 1999?
Offer a terse response. -7709. What is the difference between the Number of refugees in Cameroon in 1998 and the Number of refugees in Mauritania in 1999?
Offer a very short reply. -2.86e+04. What is the difference between the Number of refugees in Cameroon in 1998 and the Number of refugees in Philippines in 1999?
Your answer should be compact. -4.42e+04. What is the difference between the Number of refugees of Kazakhstan in 1998 and the Number of refugees of Mauritania in 1999?
Ensure brevity in your answer.  -9489. What is the difference between the Number of refugees of Kazakhstan in 1998 and the Number of refugees of Philippines in 1999?
Give a very brief answer. -2.51e+04. What is the difference between the Number of refugees of Mauritania in 1998 and the Number of refugees of Philippines in 1999?
Provide a succinct answer. 2.47e+04. What is the difference between the Number of refugees in Cameroon in 1998 and the Number of refugees in Kazakhstan in 2000?
Your answer should be compact. -1189. What is the difference between the Number of refugees of Cameroon in 1998 and the Number of refugees of Mauritania in 2000?
Provide a succinct answer. -2.84e+04. What is the difference between the Number of refugees of Cameroon in 1998 and the Number of refugees of Philippines in 2000?
Offer a terse response. -4.41e+04. What is the difference between the Number of refugees in Kazakhstan in 1998 and the Number of refugees in Mauritania in 2000?
Your answer should be very brief. -9293. What is the difference between the Number of refugees of Kazakhstan in 1998 and the Number of refugees of Philippines in 2000?
Offer a very short reply. -2.50e+04. What is the difference between the Number of refugees in Mauritania in 1998 and the Number of refugees in Philippines in 2000?
Provide a short and direct response. 2.47e+04. What is the difference between the Number of refugees of Cameroon in 1998 and the Number of refugees of Kazakhstan in 2001?
Offer a terse response. -1455. What is the difference between the Number of refugees in Cameroon in 1998 and the Number of refugees in Mauritania in 2001?
Give a very brief answer. -2.85e+04. What is the difference between the Number of refugees of Cameroon in 1998 and the Number of refugees of Philippines in 2001?
Your answer should be very brief. -4.41e+04. What is the difference between the Number of refugees in Kazakhstan in 1998 and the Number of refugees in Mauritania in 2001?
Your answer should be compact. -9403. What is the difference between the Number of refugees of Kazakhstan in 1998 and the Number of refugees of Philippines in 2001?
Offer a very short reply. -2.50e+04. What is the difference between the Number of refugees in Mauritania in 1998 and the Number of refugees in Philippines in 2001?
Give a very brief answer. 2.48e+04. What is the difference between the Number of refugees in Cameroon in 1999 and the Number of refugees in Kazakhstan in 2000?
Give a very brief answer. -883. What is the difference between the Number of refugees of Cameroon in 1999 and the Number of refugees of Mauritania in 2000?
Offer a very short reply. -2.81e+04. What is the difference between the Number of refugees in Cameroon in 1999 and the Number of refugees in Philippines in 2000?
Offer a terse response. -4.38e+04. What is the difference between the Number of refugees of Kazakhstan in 1999 and the Number of refugees of Mauritania in 2000?
Ensure brevity in your answer.  -2.07e+04. What is the difference between the Number of refugees in Kazakhstan in 1999 and the Number of refugees in Philippines in 2000?
Your answer should be compact. -3.64e+04. What is the difference between the Number of refugees of Mauritania in 1999 and the Number of refugees of Philippines in 2000?
Provide a short and direct response. -1.55e+04. What is the difference between the Number of refugees of Cameroon in 1999 and the Number of refugees of Kazakhstan in 2001?
Your answer should be compact. -1149. What is the difference between the Number of refugees in Cameroon in 1999 and the Number of refugees in Mauritania in 2001?
Give a very brief answer. -2.82e+04. What is the difference between the Number of refugees in Cameroon in 1999 and the Number of refugees in Philippines in 2001?
Provide a succinct answer. -4.38e+04. What is the difference between the Number of refugees of Kazakhstan in 1999 and the Number of refugees of Mauritania in 2001?
Keep it short and to the point. -2.08e+04. What is the difference between the Number of refugees of Kazakhstan in 1999 and the Number of refugees of Philippines in 2001?
Offer a very short reply. -3.64e+04. What is the difference between the Number of refugees of Mauritania in 1999 and the Number of refugees of Philippines in 2001?
Give a very brief answer. -1.55e+04. What is the difference between the Number of refugees in Cameroon in 2000 and the Number of refugees in Kazakhstan in 2001?
Provide a succinct answer. -741. What is the difference between the Number of refugees of Cameroon in 2000 and the Number of refugees of Mauritania in 2001?
Give a very brief answer. -2.78e+04. What is the difference between the Number of refugees in Cameroon in 2000 and the Number of refugees in Philippines in 2001?
Offer a terse response. -4.34e+04. What is the difference between the Number of refugees in Kazakhstan in 2000 and the Number of refugees in Mauritania in 2001?
Your answer should be very brief. -2.73e+04. What is the difference between the Number of refugees of Kazakhstan in 2000 and the Number of refugees of Philippines in 2001?
Ensure brevity in your answer.  -4.29e+04. What is the difference between the Number of refugees of Mauritania in 2000 and the Number of refugees of Philippines in 2001?
Give a very brief answer. -1.57e+04. What is the average Number of refugees in Cameroon per year?
Provide a short and direct response. 1801.25. What is the average Number of refugees of Kazakhstan per year?
Offer a terse response. 1.45e+04. What is the average Number of refugees of Mauritania per year?
Your answer should be very brief. 5.82e+04. What is the average Number of refugees in Philippines per year?
Ensure brevity in your answer.  2.30e+04. In the year 1994, what is the difference between the Number of refugees in Cameroon and Number of refugees in Kazakhstan?
Your response must be concise. 211. In the year 1994, what is the difference between the Number of refugees in Cameroon and Number of refugees in Mauritania?
Your response must be concise. -6.78e+04. In the year 1994, what is the difference between the Number of refugees in Cameroon and Number of refugees in Philippines?
Your answer should be very brief. -198. In the year 1994, what is the difference between the Number of refugees of Kazakhstan and Number of refugees of Mauritania?
Ensure brevity in your answer.  -6.80e+04. In the year 1994, what is the difference between the Number of refugees in Kazakhstan and Number of refugees in Philippines?
Your answer should be compact. -409. In the year 1994, what is the difference between the Number of refugees of Mauritania and Number of refugees of Philippines?
Ensure brevity in your answer.  6.76e+04. In the year 1995, what is the difference between the Number of refugees in Cameroon and Number of refugees in Kazakhstan?
Provide a succinct answer. 1878. In the year 1995, what is the difference between the Number of refugees in Cameroon and Number of refugees in Mauritania?
Ensure brevity in your answer.  -8.23e+04. In the year 1995, what is the difference between the Number of refugees in Cameroon and Number of refugees in Philippines?
Your answer should be very brief. 1501. In the year 1995, what is the difference between the Number of refugees in Kazakhstan and Number of refugees in Mauritania?
Offer a very short reply. -8.42e+04. In the year 1995, what is the difference between the Number of refugees of Kazakhstan and Number of refugees of Philippines?
Offer a very short reply. -377. In the year 1995, what is the difference between the Number of refugees in Mauritania and Number of refugees in Philippines?
Provide a succinct answer. 8.38e+04. In the year 1996, what is the difference between the Number of refugees in Cameroon and Number of refugees in Kazakhstan?
Provide a short and direct response. -3.81e+04. In the year 1996, what is the difference between the Number of refugees in Cameroon and Number of refugees in Mauritania?
Your answer should be very brief. -8.11e+04. In the year 1996, what is the difference between the Number of refugees in Cameroon and Number of refugees in Philippines?
Offer a very short reply. 1511. In the year 1996, what is the difference between the Number of refugees in Kazakhstan and Number of refugees in Mauritania?
Give a very brief answer. -4.31e+04. In the year 1996, what is the difference between the Number of refugees in Kazakhstan and Number of refugees in Philippines?
Your response must be concise. 3.96e+04. In the year 1996, what is the difference between the Number of refugees in Mauritania and Number of refugees in Philippines?
Offer a terse response. 8.26e+04. In the year 1997, what is the difference between the Number of refugees in Cameroon and Number of refugees in Kazakhstan?
Give a very brief answer. -3.85e+04. In the year 1997, what is the difference between the Number of refugees of Cameroon and Number of refugees of Mauritania?
Give a very brief answer. -6.80e+04. In the year 1997, what is the difference between the Number of refugees in Cameroon and Number of refugees in Philippines?
Make the answer very short. 1733. In the year 1997, what is the difference between the Number of refugees in Kazakhstan and Number of refugees in Mauritania?
Keep it short and to the point. -2.95e+04. In the year 1997, what is the difference between the Number of refugees of Kazakhstan and Number of refugees of Philippines?
Your answer should be very brief. 4.02e+04. In the year 1997, what is the difference between the Number of refugees in Mauritania and Number of refugees in Philippines?
Your answer should be very brief. 6.98e+04. In the year 1998, what is the difference between the Number of refugees of Cameroon and Number of refugees of Kazakhstan?
Your response must be concise. -1.91e+04. In the year 1998, what is the difference between the Number of refugees in Cameroon and Number of refugees in Mauritania?
Your response must be concise. -6.89e+04. In the year 1998, what is the difference between the Number of refugees in Cameroon and Number of refugees in Philippines?
Offer a very short reply. -4.42e+04. In the year 1998, what is the difference between the Number of refugees in Kazakhstan and Number of refugees in Mauritania?
Keep it short and to the point. -4.98e+04. In the year 1998, what is the difference between the Number of refugees of Kazakhstan and Number of refugees of Philippines?
Ensure brevity in your answer.  -2.51e+04. In the year 1998, what is the difference between the Number of refugees in Mauritania and Number of refugees in Philippines?
Your response must be concise. 2.46e+04. In the year 1999, what is the difference between the Number of refugees in Cameroon and Number of refugees in Kazakhstan?
Your response must be concise. -7403. In the year 1999, what is the difference between the Number of refugees of Cameroon and Number of refugees of Mauritania?
Your response must be concise. -2.83e+04. In the year 1999, what is the difference between the Number of refugees in Cameroon and Number of refugees in Philippines?
Your answer should be compact. -4.39e+04. In the year 1999, what is the difference between the Number of refugees in Kazakhstan and Number of refugees in Mauritania?
Your response must be concise. -2.09e+04. In the year 1999, what is the difference between the Number of refugees of Kazakhstan and Number of refugees of Philippines?
Your answer should be very brief. -3.65e+04. In the year 1999, what is the difference between the Number of refugees of Mauritania and Number of refugees of Philippines?
Keep it short and to the point. -1.56e+04. In the year 2000, what is the difference between the Number of refugees of Cameroon and Number of refugees of Kazakhstan?
Provide a short and direct response. -475. In the year 2000, what is the difference between the Number of refugees of Cameroon and Number of refugees of Mauritania?
Your response must be concise. -2.77e+04. In the year 2000, what is the difference between the Number of refugees of Cameroon and Number of refugees of Philippines?
Offer a very short reply. -4.34e+04. In the year 2000, what is the difference between the Number of refugees of Kazakhstan and Number of refugees of Mauritania?
Give a very brief answer. -2.72e+04. In the year 2000, what is the difference between the Number of refugees of Kazakhstan and Number of refugees of Philippines?
Make the answer very short. -4.29e+04. In the year 2000, what is the difference between the Number of refugees of Mauritania and Number of refugees of Philippines?
Make the answer very short. -1.57e+04. In the year 2001, what is the difference between the Number of refugees in Cameroon and Number of refugees in Kazakhstan?
Offer a very short reply. -79. In the year 2001, what is the difference between the Number of refugees of Cameroon and Number of refugees of Mauritania?
Give a very brief answer. -2.71e+04. In the year 2001, what is the difference between the Number of refugees of Cameroon and Number of refugees of Philippines?
Offer a terse response. -4.27e+04. In the year 2001, what is the difference between the Number of refugees in Kazakhstan and Number of refugees in Mauritania?
Your answer should be compact. -2.71e+04. In the year 2001, what is the difference between the Number of refugees of Kazakhstan and Number of refugees of Philippines?
Your response must be concise. -4.27e+04. In the year 2001, what is the difference between the Number of refugees in Mauritania and Number of refugees in Philippines?
Provide a short and direct response. -1.56e+04. What is the ratio of the Number of refugees in Cameroon in 1994 to that in 1995?
Keep it short and to the point. 0.12. What is the ratio of the Number of refugees of Kazakhstan in 1994 to that in 1995?
Keep it short and to the point. 0.19. What is the ratio of the Number of refugees in Mauritania in 1994 to that in 1995?
Your answer should be compact. 0.81. What is the ratio of the Number of refugees of Philippines in 1994 to that in 1995?
Your response must be concise. 0.84. What is the ratio of the Number of refugees of Cameroon in 1994 to that in 1996?
Provide a succinct answer. 0.11. What is the ratio of the Number of refugees in Kazakhstan in 1994 to that in 1996?
Ensure brevity in your answer.  0. What is the ratio of the Number of refugees of Mauritania in 1994 to that in 1996?
Provide a short and direct response. 0.82. What is the ratio of the Number of refugees of Philippines in 1994 to that in 1996?
Provide a succinct answer. 0.73. What is the ratio of the Number of refugees of Cameroon in 1994 to that in 1997?
Your answer should be compact. 0.11. What is the ratio of the Number of refugees in Kazakhstan in 1994 to that in 1997?
Make the answer very short. 0. What is the ratio of the Number of refugees of Mauritania in 1994 to that in 1997?
Offer a terse response. 0.97. What is the ratio of the Number of refugees of Philippines in 1994 to that in 1997?
Your answer should be compact. 0.83. What is the ratio of the Number of refugees in Cameroon in 1994 to that in 1998?
Provide a succinct answer. 0.18. What is the ratio of the Number of refugees of Kazakhstan in 1994 to that in 1998?
Provide a short and direct response. 0. What is the ratio of the Number of refugees in Mauritania in 1994 to that in 1998?
Offer a terse response. 0.97. What is the ratio of the Number of refugees of Philippines in 1994 to that in 1998?
Keep it short and to the point. 0.01. What is the ratio of the Number of refugees of Cameroon in 1994 to that in 1999?
Keep it short and to the point. 0.14. What is the ratio of the Number of refugees in Kazakhstan in 1994 to that in 1999?
Give a very brief answer. 0. What is the ratio of the Number of refugees in Mauritania in 1994 to that in 1999?
Provide a short and direct response. 2.27. What is the ratio of the Number of refugees in Philippines in 1994 to that in 1999?
Provide a succinct answer. 0.01. What is the ratio of the Number of refugees in Cameroon in 1994 to that in 2000?
Your answer should be compact. 0.12. What is the ratio of the Number of refugees in Kazakhstan in 1994 to that in 2000?
Provide a succinct answer. 0.01. What is the ratio of the Number of refugees in Mauritania in 1994 to that in 2000?
Your answer should be very brief. 2.29. What is the ratio of the Number of refugees in Philippines in 1994 to that in 2000?
Make the answer very short. 0.01. What is the ratio of the Number of refugees in Cameroon in 1994 to that in 2001?
Your response must be concise. 0.09. What is the ratio of the Number of refugees in Kazakhstan in 1994 to that in 2001?
Provide a succinct answer. 0.01. What is the ratio of the Number of refugees in Mauritania in 1994 to that in 2001?
Keep it short and to the point. 2.28. What is the ratio of the Number of refugees of Philippines in 1994 to that in 2001?
Your answer should be compact. 0.01. What is the ratio of the Number of refugees in Cameroon in 1995 to that in 1996?
Your response must be concise. 0.96. What is the ratio of the Number of refugees of Kazakhstan in 1995 to that in 1996?
Keep it short and to the point. 0. What is the ratio of the Number of refugees in Philippines in 1995 to that in 1996?
Your response must be concise. 0.86. What is the ratio of the Number of refugees of Cameroon in 1995 to that in 1997?
Provide a succinct answer. 0.89. What is the ratio of the Number of refugees in Kazakhstan in 1995 to that in 1997?
Offer a terse response. 0. What is the ratio of the Number of refugees of Mauritania in 1995 to that in 1997?
Your response must be concise. 1.2. What is the ratio of the Number of refugees of Philippines in 1995 to that in 1997?
Make the answer very short. 0.98. What is the ratio of the Number of refugees of Cameroon in 1995 to that in 1998?
Provide a short and direct response. 1.5. What is the ratio of the Number of refugees of Kazakhstan in 1995 to that in 1998?
Your answer should be compact. 0.01. What is the ratio of the Number of refugees in Mauritania in 1995 to that in 1998?
Offer a terse response. 1.2. What is the ratio of the Number of refugees in Philippines in 1995 to that in 1998?
Offer a terse response. 0.01. What is the ratio of the Number of refugees of Cameroon in 1995 to that in 1999?
Your answer should be compact. 1.22. What is the ratio of the Number of refugees in Kazakhstan in 1995 to that in 1999?
Provide a short and direct response. 0.02. What is the ratio of the Number of refugees in Mauritania in 1995 to that in 1999?
Ensure brevity in your answer.  2.82. What is the ratio of the Number of refugees of Philippines in 1995 to that in 1999?
Give a very brief answer. 0.01. What is the ratio of the Number of refugees of Cameroon in 1995 to that in 2000?
Provide a succinct answer. 0.98. What is the ratio of the Number of refugees in Kazakhstan in 1995 to that in 2000?
Your answer should be very brief. 0.05. What is the ratio of the Number of refugees in Mauritania in 1995 to that in 2000?
Provide a short and direct response. 2.83. What is the ratio of the Number of refugees in Philippines in 1995 to that in 2000?
Keep it short and to the point. 0.01. What is the ratio of the Number of refugees in Cameroon in 1995 to that in 2001?
Offer a terse response. 0.74. What is the ratio of the Number of refugees in Kazakhstan in 1995 to that in 2001?
Offer a terse response. 0.05. What is the ratio of the Number of refugees of Mauritania in 1995 to that in 2001?
Offer a very short reply. 2.82. What is the ratio of the Number of refugees of Philippines in 1995 to that in 2001?
Offer a very short reply. 0.01. What is the ratio of the Number of refugees in Cameroon in 1996 to that in 1997?
Make the answer very short. 0.93. What is the ratio of the Number of refugees in Kazakhstan in 1996 to that in 1997?
Your answer should be compact. 0.98. What is the ratio of the Number of refugees of Mauritania in 1996 to that in 1997?
Make the answer very short. 1.18. What is the ratio of the Number of refugees in Philippines in 1996 to that in 1997?
Provide a succinct answer. 1.14. What is the ratio of the Number of refugees of Cameroon in 1996 to that in 1998?
Keep it short and to the point. 1.56. What is the ratio of the Number of refugees in Kazakhstan in 1996 to that in 1998?
Provide a short and direct response. 1.96. What is the ratio of the Number of refugees of Mauritania in 1996 to that in 1998?
Ensure brevity in your answer.  1.19. What is the ratio of the Number of refugees in Philippines in 1996 to that in 1998?
Give a very brief answer. 0.01. What is the ratio of the Number of refugees in Cameroon in 1996 to that in 1999?
Ensure brevity in your answer.  1.28. What is the ratio of the Number of refugees of Kazakhstan in 1996 to that in 1999?
Offer a very short reply. 4.43. What is the ratio of the Number of refugees in Mauritania in 1996 to that in 1999?
Provide a succinct answer. 2.78. What is the ratio of the Number of refugees in Philippines in 1996 to that in 1999?
Your answer should be very brief. 0.01. What is the ratio of the Number of refugees of Cameroon in 1996 to that in 2000?
Offer a terse response. 1.02. What is the ratio of the Number of refugees of Kazakhstan in 1996 to that in 2000?
Make the answer very short. 15.83. What is the ratio of the Number of refugees of Mauritania in 1996 to that in 2000?
Give a very brief answer. 2.8. What is the ratio of the Number of refugees of Philippines in 1996 to that in 2000?
Provide a succinct answer. 0.01. What is the ratio of the Number of refugees in Cameroon in 1996 to that in 2001?
Give a very brief answer. 0.77. What is the ratio of the Number of refugees in Kazakhstan in 1996 to that in 2001?
Ensure brevity in your answer.  14.33. What is the ratio of the Number of refugees of Mauritania in 1996 to that in 2001?
Your answer should be very brief. 2.79. What is the ratio of the Number of refugees of Philippines in 1996 to that in 2001?
Offer a terse response. 0.01. What is the ratio of the Number of refugees of Cameroon in 1997 to that in 1998?
Ensure brevity in your answer.  1.68. What is the ratio of the Number of refugees in Kazakhstan in 1997 to that in 1998?
Your answer should be compact. 1.99. What is the ratio of the Number of refugees of Philippines in 1997 to that in 1998?
Give a very brief answer. 0.01. What is the ratio of the Number of refugees of Cameroon in 1997 to that in 1999?
Provide a short and direct response. 1.37. What is the ratio of the Number of refugees of Kazakhstan in 1997 to that in 1999?
Ensure brevity in your answer.  4.5. What is the ratio of the Number of refugees in Mauritania in 1997 to that in 1999?
Offer a terse response. 2.35. What is the ratio of the Number of refugees of Philippines in 1997 to that in 1999?
Your answer should be very brief. 0.01. What is the ratio of the Number of refugees of Cameroon in 1997 to that in 2000?
Your response must be concise. 1.1. What is the ratio of the Number of refugees of Kazakhstan in 1997 to that in 2000?
Your answer should be compact. 16.07. What is the ratio of the Number of refugees in Mauritania in 1997 to that in 2000?
Your answer should be very brief. 2.36. What is the ratio of the Number of refugees in Philippines in 1997 to that in 2000?
Provide a succinct answer. 0.01. What is the ratio of the Number of refugees of Cameroon in 1997 to that in 2001?
Your answer should be compact. 0.83. What is the ratio of the Number of refugees of Kazakhstan in 1997 to that in 2001?
Your response must be concise. 14.55. What is the ratio of the Number of refugees of Mauritania in 1997 to that in 2001?
Provide a succinct answer. 2.35. What is the ratio of the Number of refugees of Philippines in 1997 to that in 2001?
Provide a short and direct response. 0.01. What is the ratio of the Number of refugees of Cameroon in 1998 to that in 1999?
Provide a short and direct response. 0.81. What is the ratio of the Number of refugees of Kazakhstan in 1998 to that in 1999?
Ensure brevity in your answer.  2.26. What is the ratio of the Number of refugees of Mauritania in 1998 to that in 1999?
Ensure brevity in your answer.  2.34. What is the ratio of the Number of refugees of Philippines in 1998 to that in 1999?
Make the answer very short. 1. What is the ratio of the Number of refugees in Cameroon in 1998 to that in 2000?
Ensure brevity in your answer.  0.65. What is the ratio of the Number of refugees of Kazakhstan in 1998 to that in 2000?
Offer a very short reply. 8.06. What is the ratio of the Number of refugees in Mauritania in 1998 to that in 2000?
Offer a terse response. 2.36. What is the ratio of the Number of refugees of Philippines in 1998 to that in 2000?
Your answer should be compact. 1. What is the ratio of the Number of refugees in Cameroon in 1998 to that in 2001?
Provide a short and direct response. 0.49. What is the ratio of the Number of refugees of Kazakhstan in 1998 to that in 2001?
Offer a very short reply. 7.3. What is the ratio of the Number of refugees in Mauritania in 1998 to that in 2001?
Your answer should be very brief. 2.35. What is the ratio of the Number of refugees in Philippines in 1998 to that in 2001?
Keep it short and to the point. 1. What is the ratio of the Number of refugees of Cameroon in 1999 to that in 2000?
Your answer should be very brief. 0.8. What is the ratio of the Number of refugees in Kazakhstan in 1999 to that in 2000?
Your answer should be compact. 3.57. What is the ratio of the Number of refugees of Mauritania in 1999 to that in 2000?
Ensure brevity in your answer.  1.01. What is the ratio of the Number of refugees of Cameroon in 1999 to that in 2001?
Your response must be concise. 0.61. What is the ratio of the Number of refugees of Kazakhstan in 1999 to that in 2001?
Offer a very short reply. 3.23. What is the ratio of the Number of refugees in Mauritania in 1999 to that in 2001?
Your response must be concise. 1. What is the ratio of the Number of refugees of Cameroon in 2000 to that in 2001?
Your answer should be compact. 0.76. What is the ratio of the Number of refugees of Kazakhstan in 2000 to that in 2001?
Provide a short and direct response. 0.91. What is the difference between the highest and the second highest Number of refugees in Cameroon?
Your response must be concise. 466. What is the difference between the highest and the second highest Number of refugees in Kazakhstan?
Ensure brevity in your answer.  611. What is the difference between the highest and the second highest Number of refugees in Mauritania?
Offer a terse response. 1078. What is the difference between the highest and the lowest Number of refugees of Cameroon?
Make the answer very short. 2486. What is the difference between the highest and the lowest Number of refugees in Kazakhstan?
Offer a terse response. 4.07e+04. What is the difference between the highest and the lowest Number of refugees of Mauritania?
Provide a succinct answer. 5.46e+04. What is the difference between the highest and the lowest Number of refugees in Philippines?
Provide a short and direct response. 4.52e+04. 